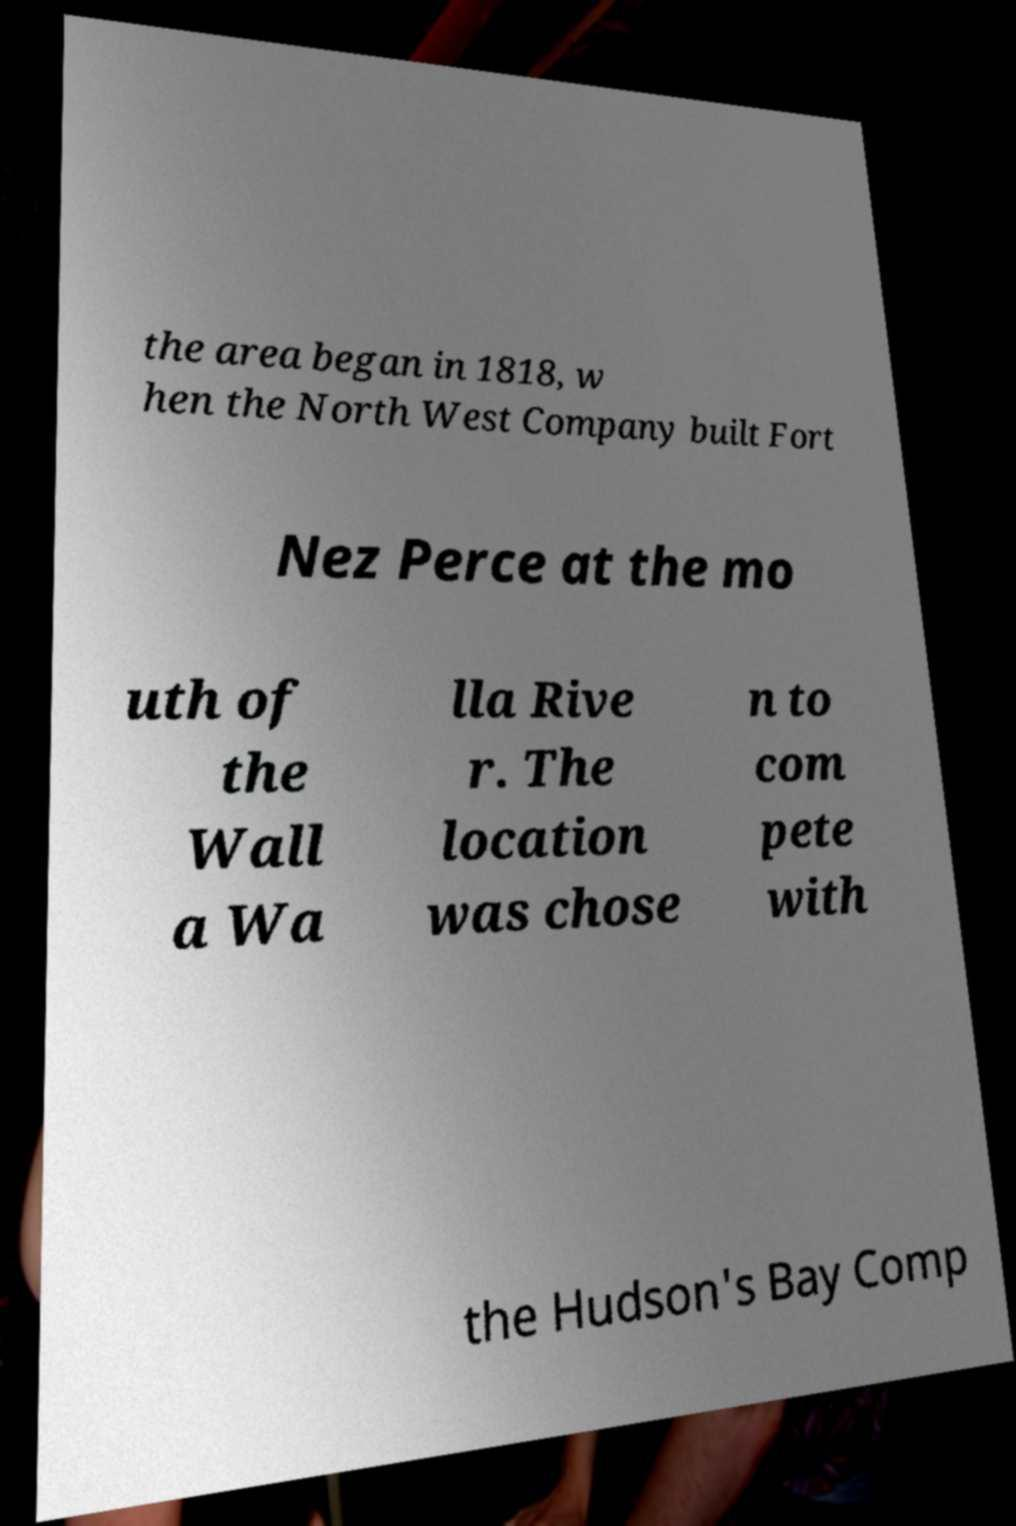Can you accurately transcribe the text from the provided image for me? the area began in 1818, w hen the North West Company built Fort Nez Perce at the mo uth of the Wall a Wa lla Rive r. The location was chose n to com pete with the Hudson's Bay Comp 